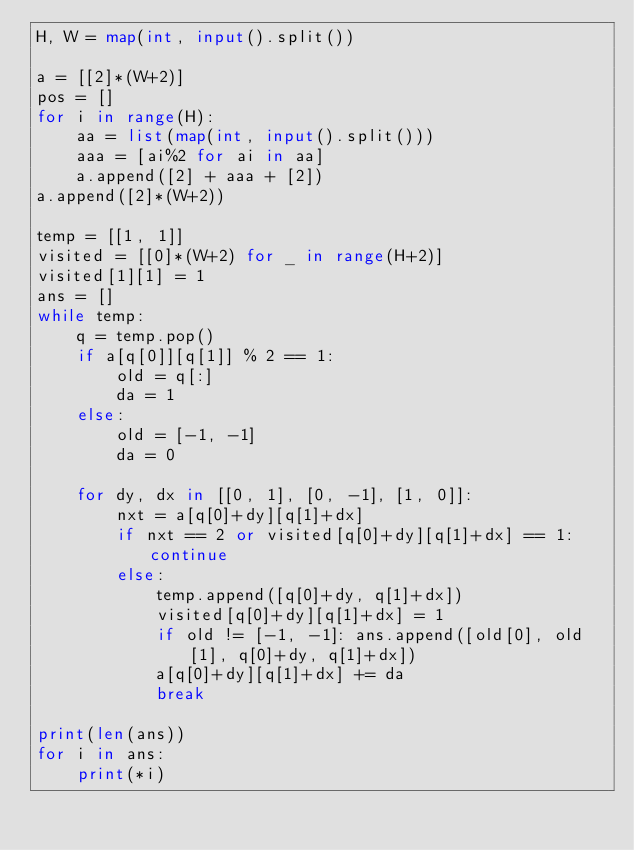Convert code to text. <code><loc_0><loc_0><loc_500><loc_500><_Python_>H, W = map(int, input().split())

a = [[2]*(W+2)]
pos = []
for i in range(H):
    aa = list(map(int, input().split()))
    aaa = [ai%2 for ai in aa]
    a.append([2] + aaa + [2])
a.append([2]*(W+2))

temp = [[1, 1]]
visited = [[0]*(W+2) for _ in range(H+2)]
visited[1][1] = 1
ans = []
while temp:
    q = temp.pop()
    if a[q[0]][q[1]] % 2 == 1:
        old = q[:]
        da = 1
    else:
        old = [-1, -1]
        da = 0
        
    for dy, dx in [[0, 1], [0, -1], [1, 0]]:
        nxt = a[q[0]+dy][q[1]+dx]
        if nxt == 2 or visited[q[0]+dy][q[1]+dx] == 1: continue
        else:
            temp.append([q[0]+dy, q[1]+dx])
            visited[q[0]+dy][q[1]+dx] = 1
            if old != [-1, -1]: ans.append([old[0], old[1], q[0]+dy, q[1]+dx])
            a[q[0]+dy][q[1]+dx] += da
            break

print(len(ans))
for i in ans:
    print(*i)
      </code> 